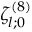<formula> <loc_0><loc_0><loc_500><loc_500>\zeta _ { l ; 0 } ^ { ( 8 ) }</formula> 